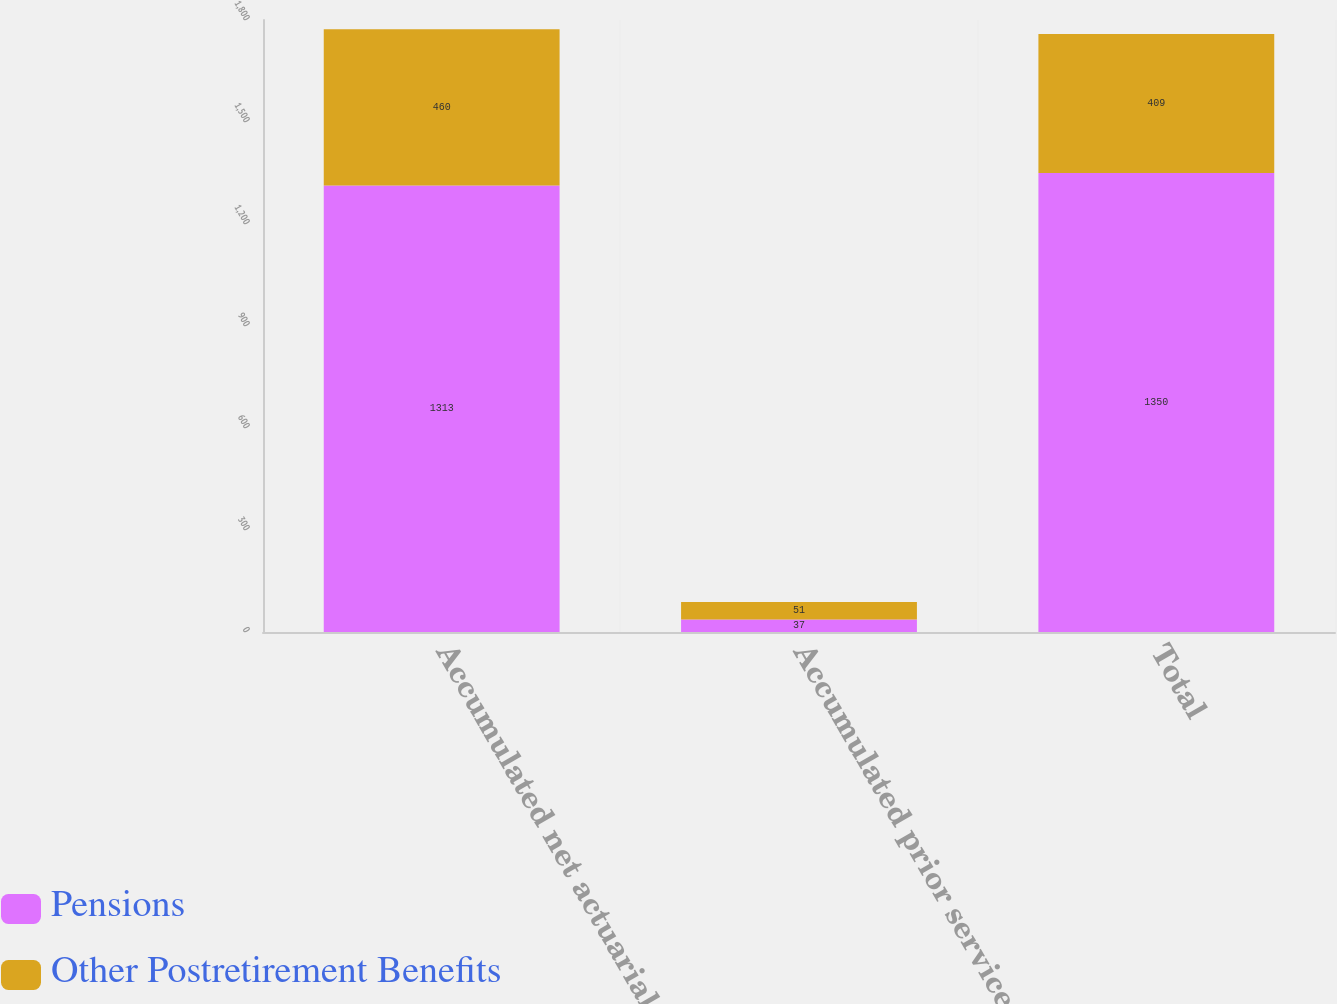Convert chart. <chart><loc_0><loc_0><loc_500><loc_500><stacked_bar_chart><ecel><fcel>Accumulated net actuarial<fcel>Accumulated prior service cost<fcel>Total<nl><fcel>Pensions<fcel>1313<fcel>37<fcel>1350<nl><fcel>Other Postretirement Benefits<fcel>460<fcel>51<fcel>409<nl></chart> 